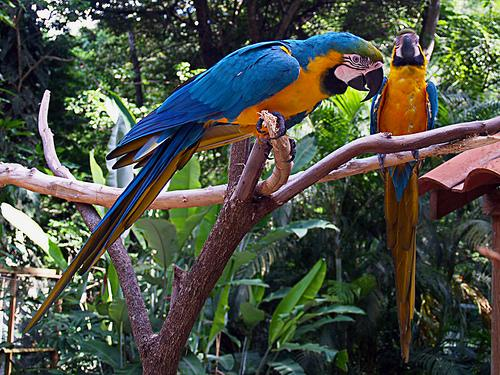Name the type of birds present and describe one interaction between the two main subjects in the image. The birds in the image are macaws, and one interaction between them could be sitting closely on the same tree branch, as if communicating to each other or resting side by side. Provide a brief description of the overall setting in the image. The image features a lush green environment with two bright blue and yellow parrots perched on tree branches, and various vegetation and structures in the background. What is the primary sentiment conveyed by this image? The primary sentiment conveyed by this image is a sense of serenity and connection with nature. Analyze the quality of the photograph in terms of composition and colors. The photograph is of high quality and offers a well-composed scene with vibrant colors, with a focus on the two blue and yellow parrots set against a lush green backdrop. Describe any man-made structures and their purpose in the image. There is a wooden and metal bird enclosure fence and a wooden roof of a parrot house, providing shelter and protection for the birds. Explain the main interaction happening between objects in the scene. The main interaction in the scene is between the two parrots perched on tree branches in a lush green foliage area, appearing as if they are socializing or resting together. Count how many birds are there in the image and describe their most distinctive features. There are two birds in the image; both are blue and yellow parrots with black beaks, blue feathers on their shoulders, long yellow tail feathers, and talons wrapped around branches. Mention the different colors present on the parrots in the photo. The parrots have Blue, yellow, black, and white colors on their body. What are some of the smaller details like parts of leaves, branches, and birds captured in the image? Some smaller details include the part of a leaf, part of a branch, part of a tree, part of a vegetation, part of a twig, part of a bird, tail of a bird, edge of a tree, and tip of a leaf. Estimate the count of different objects like trees, leaves, branches, and twigs in the image. A rough estimate of objects in the image includes at least 4 trees, 20 leaves, 10 branches, and 5 twigs. 